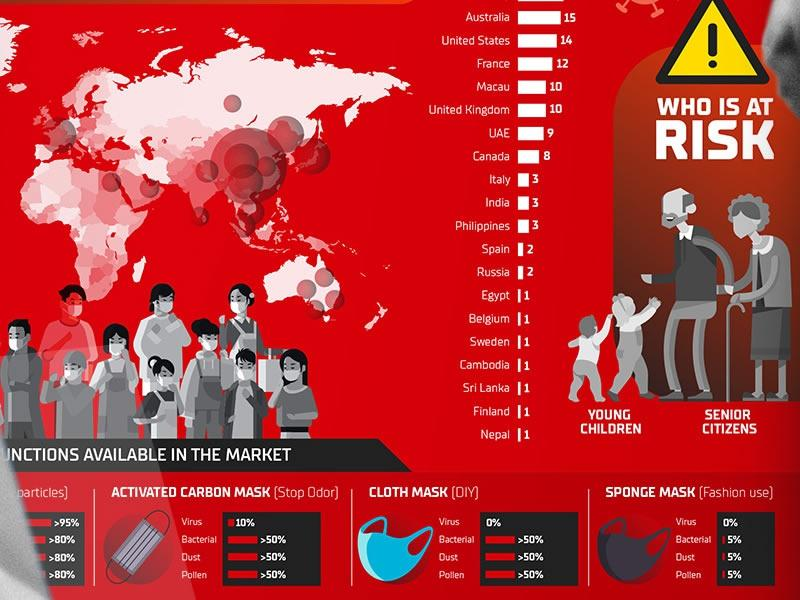Outline some significant characteristics in this image. Young children and senior citizens are at risk. The cloth mask does not provide protection against viruses. The total count of Sri Lanka and Nepal is 2. Our sponge mask provides 5% protection against bacteria, dust, and pollen. Our activated carbon mask and cloth mask offer >50% protection against bacterial, dust, and pollen particles, making them ideal for individuals looking to stay healthy and comfortable during outdoor activities. 